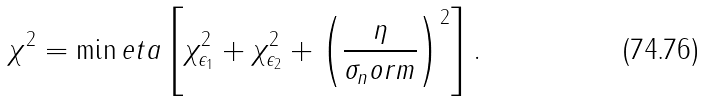<formula> <loc_0><loc_0><loc_500><loc_500>\chi ^ { 2 } = \min e t a \left [ \chi ^ { 2 } _ { \epsilon _ { 1 } } + \chi ^ { 2 } _ { \epsilon _ { 2 } } + \left ( \frac { \eta } { \sigma _ { n } o r m } \right ) ^ { 2 } \right ] .</formula> 